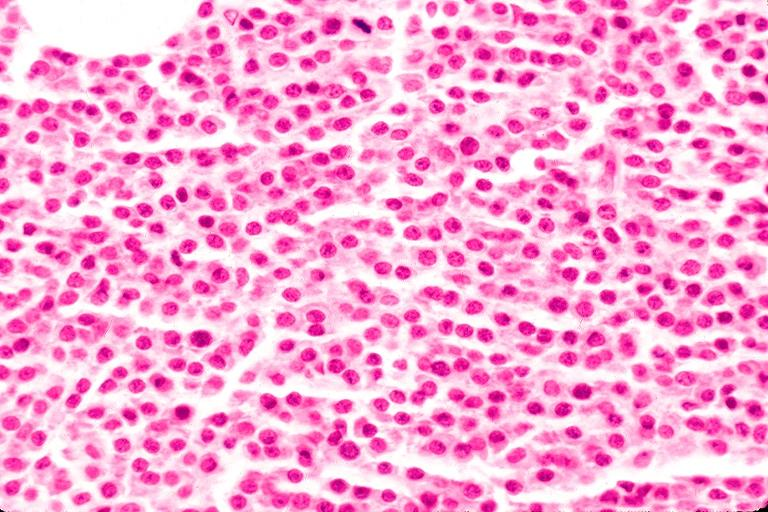where is this?
Answer the question using a single word or phrase. Oral 